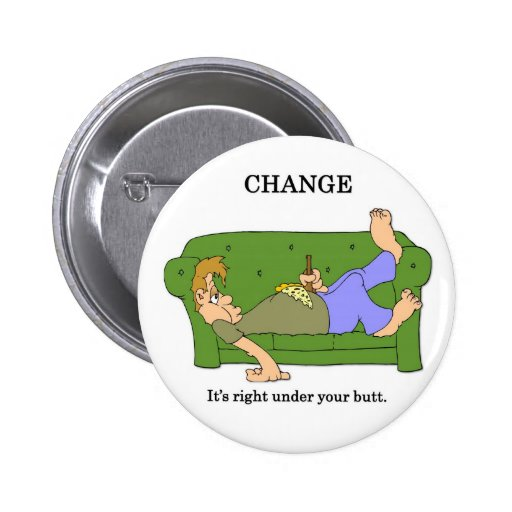Considering the juxtaposition of literal and metaphorical change in the image, how can someone apply this concept to self-improvement and personal growth? The juxtaposition of literal and metaphorical change in the image can serve as a powerful metaphor for self-improvement and personal growth. Just as one might find loose coins under the couch by merely looking, one can also discover areas for personal growth by reflecting on their current state and environment. Simple actions like reflecting on daily habits, setting small yet meaningful goals, or seeking new opportunities in routine activities can pave the way for substantial personal growth over time. It emphasizes that change doesn't always require grand gestures; sometimes, it begins with the small, overlooked elements of our daily lives. 